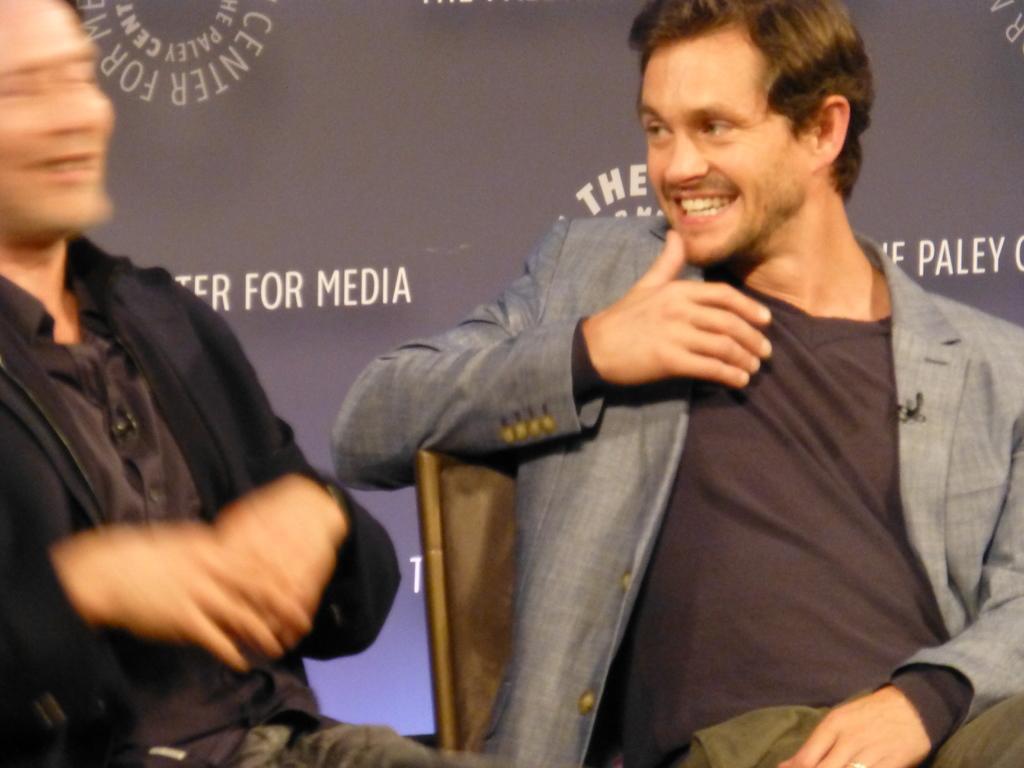How would you summarize this image in a sentence or two? In the picture we can see two men are sitting on the chairs and one man is wearing a black hoodie with shirt inside and one man is wearing blazer with brown T-shirt and in the background we can see a wall with some advertisements. 